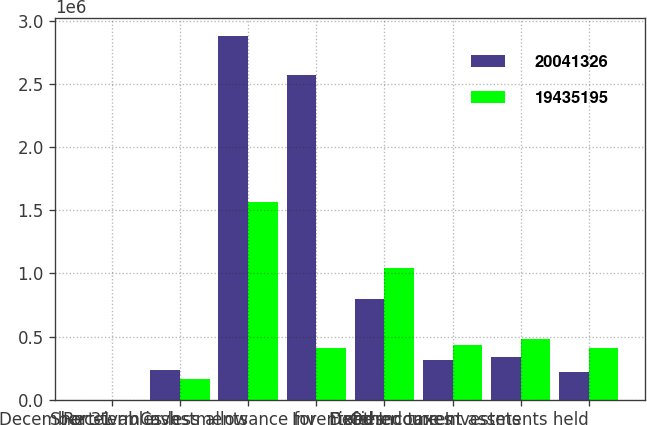Convert chart. <chart><loc_0><loc_0><loc_500><loc_500><stacked_bar_chart><ecel><fcel>December 31<fcel>Cash<fcel>Short-term investments<fcel>Receivables less allowance for<fcel>Inventories<fcel>Deferred taxes<fcel>Other current assets<fcel>Fixed Income Investments held<nl><fcel>2.00413e+07<fcel>2003<fcel>234192<fcel>2.87478e+06<fcel>2.56842e+06<fcel>796559<fcel>315350<fcel>341973<fcel>223300<nl><fcel>1.94352e+07<fcel>2002<fcel>168110<fcel>1.56791e+06<fcel>407500<fcel>1.04306e+06<fcel>435887<fcel>481074<fcel>407500<nl></chart> 